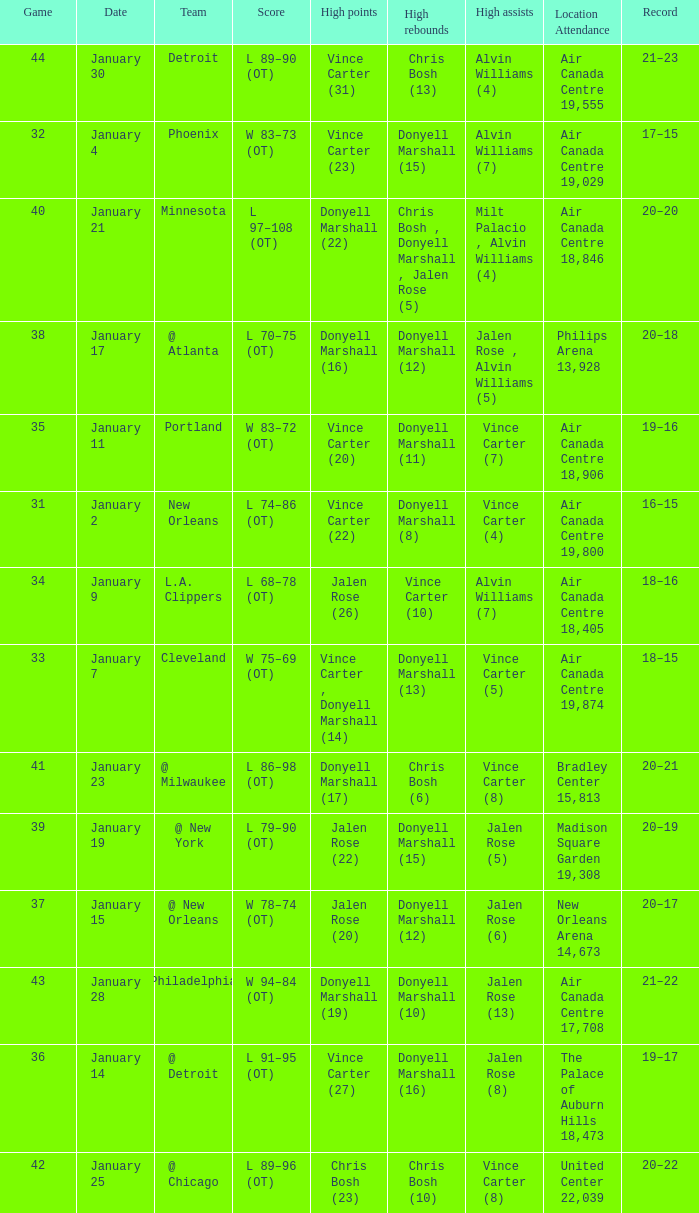Where was the game, and how many attended the game on january 2? Air Canada Centre 19,800. 